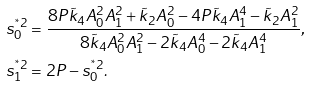Convert formula to latex. <formula><loc_0><loc_0><loc_500><loc_500>s _ { 0 } ^ { ^ { * } 2 } & = \frac { 8 P \tilde { k } _ { 4 } A _ { 0 } ^ { 2 } A _ { 1 } ^ { 2 } + \tilde { k } _ { 2 } A _ { 0 } ^ { 2 } - 4 P \tilde { k } _ { 4 } A _ { 1 } ^ { 4 } - \tilde { k } _ { 2 } A _ { 1 } ^ { 2 } } { 8 \tilde { k } _ { 4 } A _ { 0 } ^ { 2 } A _ { 1 } ^ { 2 } - 2 \tilde { k } _ { 4 } A _ { 0 } ^ { 4 } - 2 \tilde { k } _ { 4 } A _ { 1 } ^ { 4 } } , \\ s _ { 1 } ^ { ^ { * } 2 } & = 2 P - s _ { 0 } ^ { ^ { * } 2 } .</formula> 